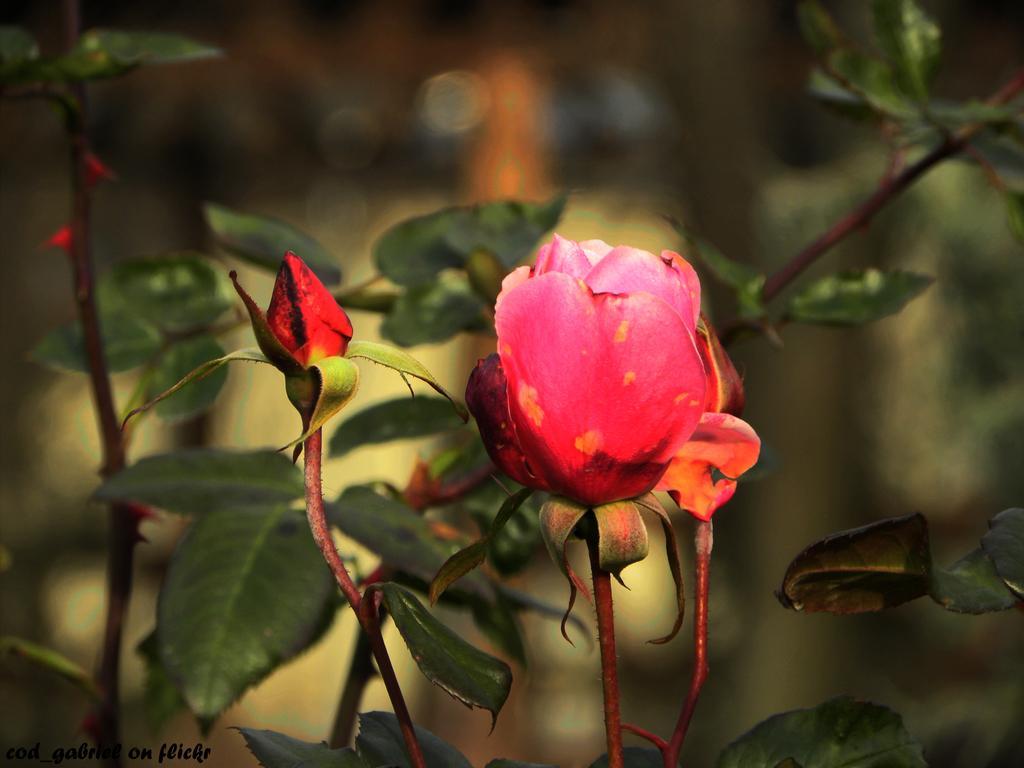In one or two sentences, can you explain what this image depicts? In this image I can see a flower which is pink, orange and red in color to a tree. I can see few leaves which are green in color and the blurry background. 